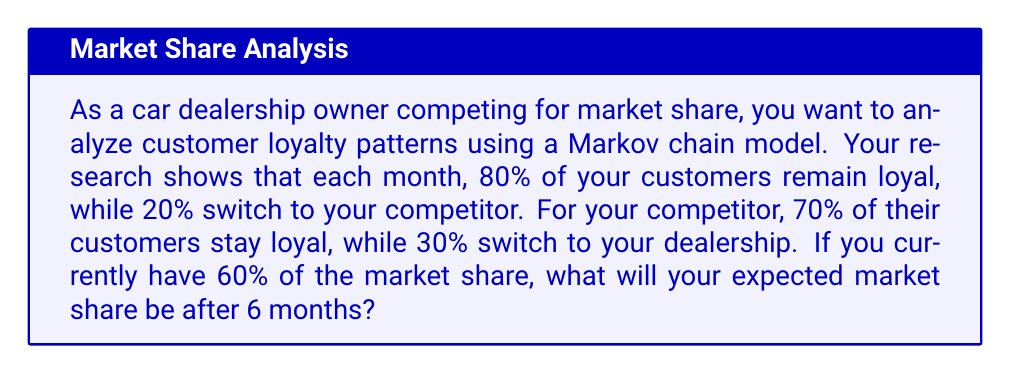What is the answer to this math problem? Let's approach this step-by-step using a Markov chain model:

1) First, let's define our transition matrix P:

   $$P = \begin{bmatrix}
   0.8 & 0.3 \\
   0.2 & 0.7
   \end{bmatrix}$$

   Where the rows represent your dealership and your competitor, respectively.

2) The initial state vector is:

   $$v_0 = \begin{bmatrix}
   0.6 \\
   0.4
   \end{bmatrix}$$

3) To find the state after 6 months, we need to calculate $P^6 \cdot v_0$

4) Let's calculate $P^6$ using matrix multiplication:

   $$P^6 = \begin{bmatrix}
   0.6316 & 0.3684 \\
   0.3684 & 0.6316
   \end{bmatrix}$$

5) Now, let's multiply $P^6$ by $v_0$:

   $$P^6 \cdot v_0 = \begin{bmatrix}
   0.6316 & 0.3684 \\
   0.3684 & 0.6316
   \end{bmatrix} \cdot \begin{bmatrix}
   0.6 \\
   0.4
   \end{bmatrix}$$

6) Calculating this:

   $$\begin{bmatrix}
   (0.6316 \cdot 0.6) + (0.3684 \cdot 0.4) \\
   (0.3684 \cdot 0.6) + (0.6316 \cdot 0.4)
   \end{bmatrix} = \begin{bmatrix}
   0.5263 \\
   0.4737
   \end{bmatrix}$$

7) The first element of this resulting vector represents your market share after 6 months.
Answer: 52.63% 